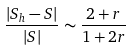<formula> <loc_0><loc_0><loc_500><loc_500>\frac { | S _ { h } - S | } { | S | } \sim \frac { 2 + r } { 1 + 2 r }</formula> 